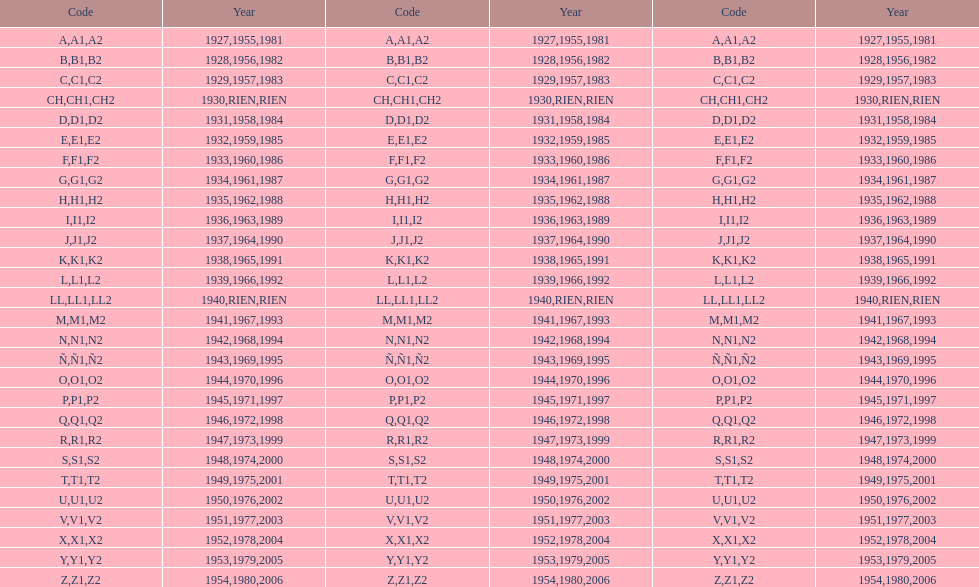How many different codes were used from 1953 to 1958? 6. 